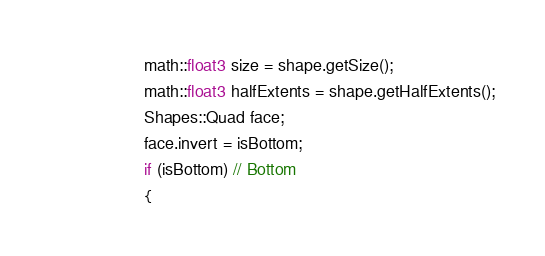<code> <loc_0><loc_0><loc_500><loc_500><_Cuda_>					math::float3 size = shape.getSize();
					math::float3 halfExtents = shape.getHalfExtents();
					Shapes::Quad face;
					face.invert = isBottom;
					if (isBottom) // Bottom
					{</code> 